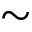<formula> <loc_0><loc_0><loc_500><loc_500>\sim</formula> 